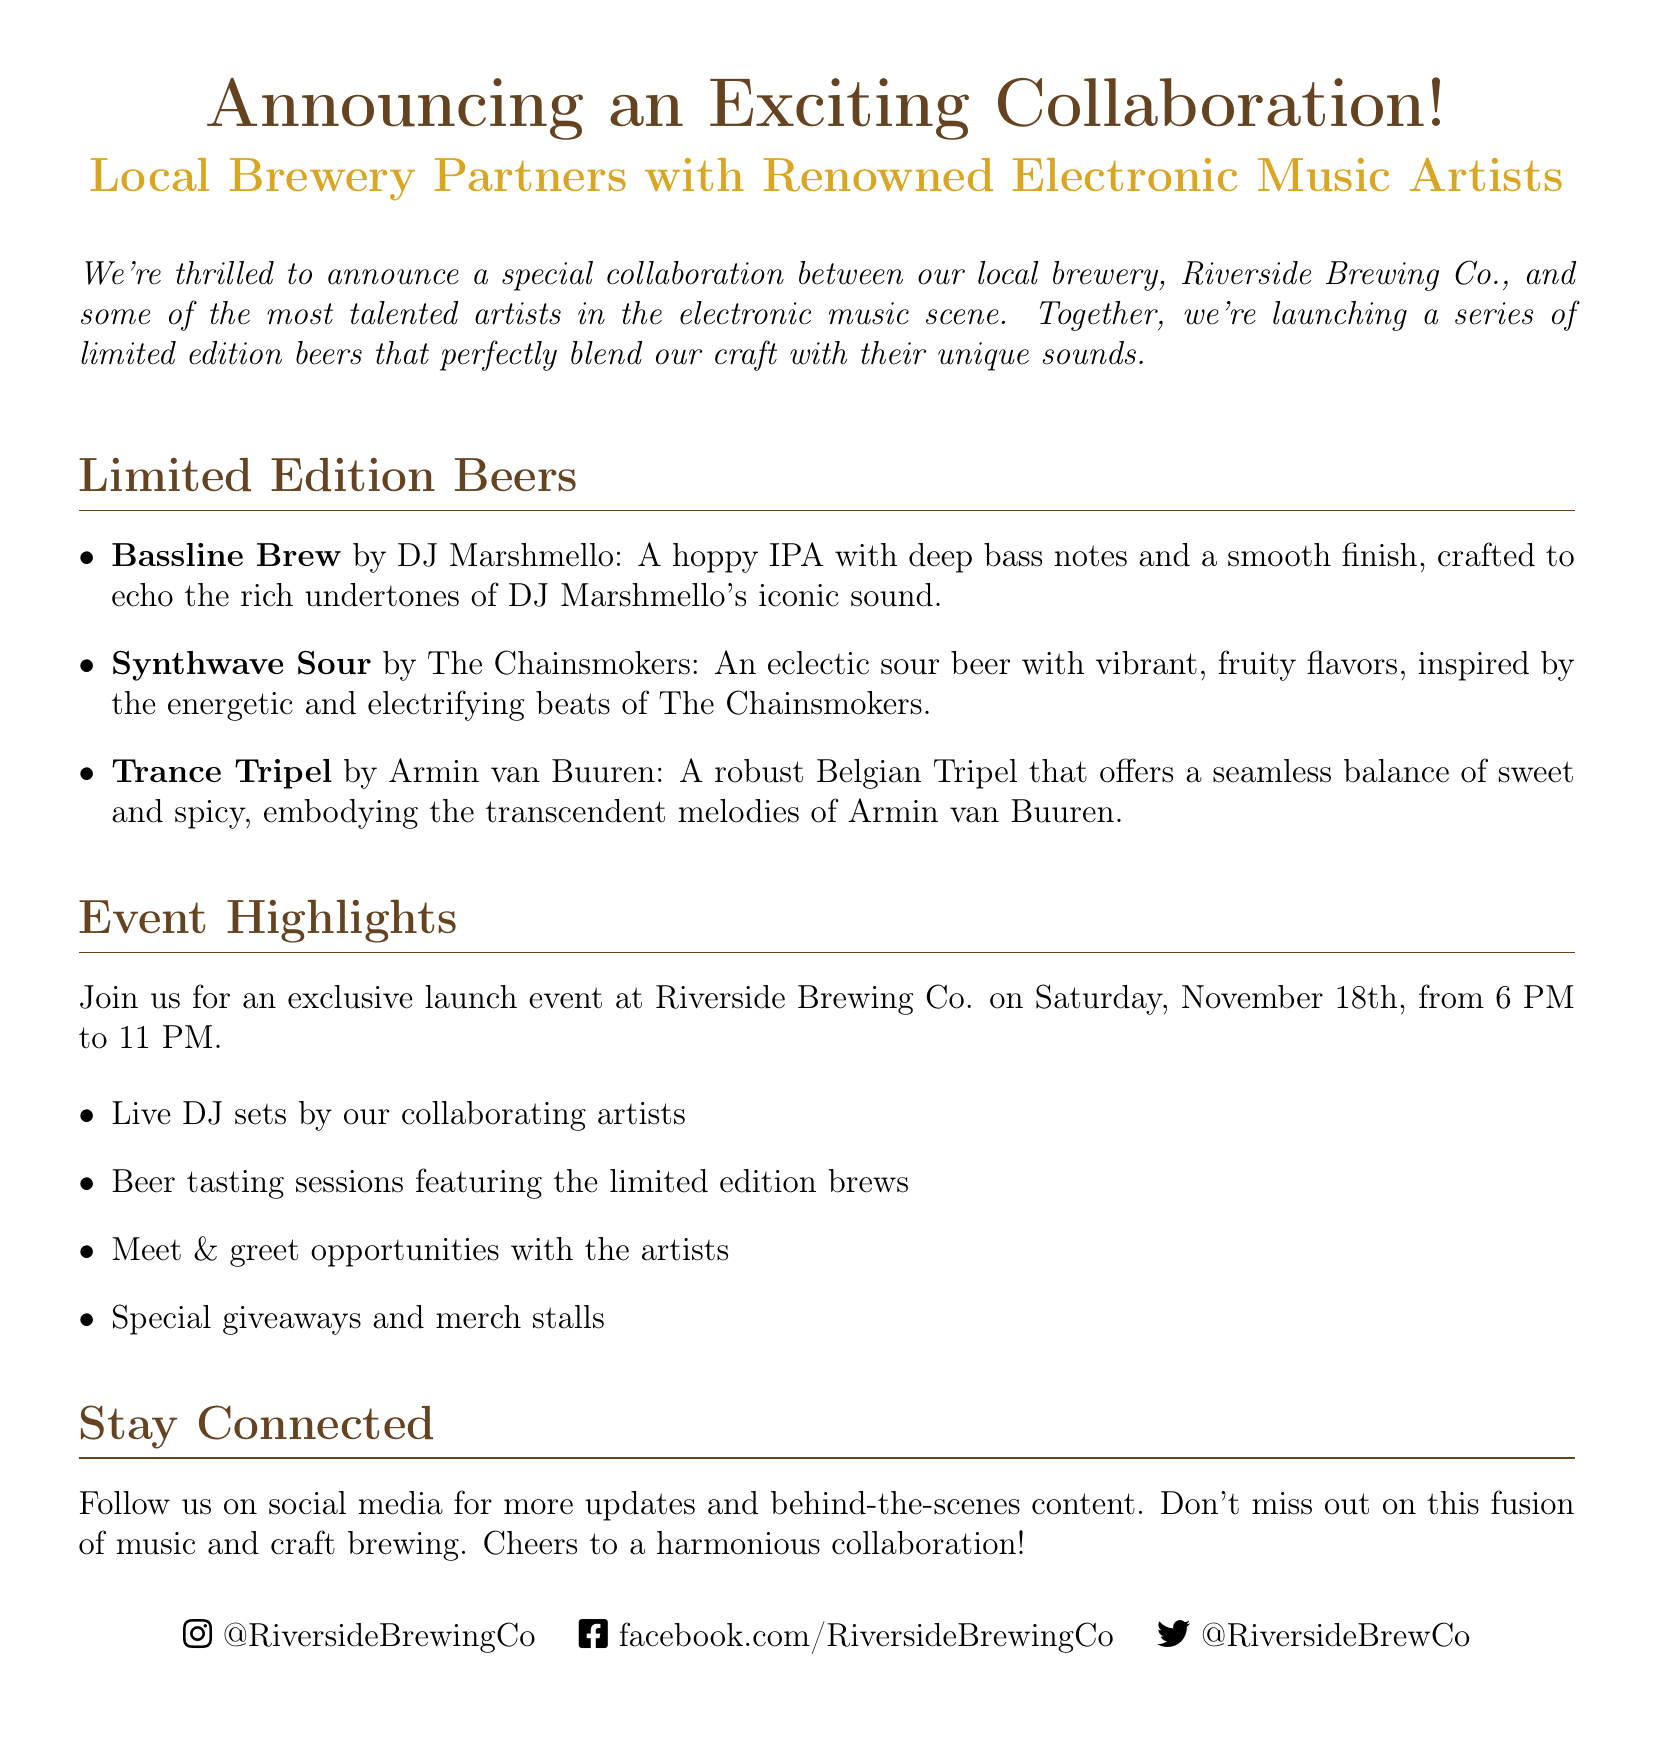What is the name of the brewery involved in the collaboration? The document specifically names Riverside Brewing Co. as the local brewery partnering with renowned electronic music artists.
Answer: Riverside Brewing Co What is the date of the launch event? The launch event is clearly stated to take place on Saturday, November 18th.
Answer: November 18th Who is the artist behind the Bassline Brew? The document lists DJ Marshmello as the creator of the Bassline Brew beer.
Answer: DJ Marshmello What type of beer is the Synthwave Sour? According to the document, Synthwave Sour is described as an eclectic sour beer.
Answer: Eclectic sour beer What is included in the event highlights? The document mentions several features of the event, including live DJ sets, beer tasting, and meet & greet opportunities.
Answer: Live DJ sets, beer tasting sessions, meet & greet opportunities How long will the event run? The document states that the event will occur from 6 PM to 11 PM, indicating a duration of 5 hours.
Answer: 5 hours What social media platforms is the brewery active on? The document specifies several platforms: Instagram, Facebook, and Twitter, included in their social media details.
Answer: Instagram, Facebook, Twitter What is the flavor profile of the Trance Tripel? The flavor profile of Trance Tripel is described as a balance of sweet and spicy, associated with Armin van Buuren.
Answer: Sweet and spicy What type of collaboration is being announced? The document introduces a collaboration between a local brewery and renowned electronic music artists, specifying the nature of the partnership.
Answer: Brewery and electronic music artists 